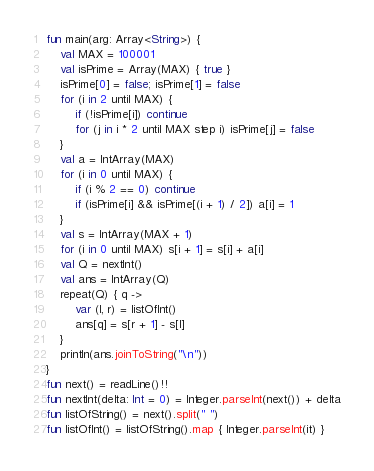Convert code to text. <code><loc_0><loc_0><loc_500><loc_500><_Kotlin_>fun main(arg: Array<String>) {
    val MAX = 100001
    val isPrime = Array(MAX) { true }
    isPrime[0] = false; isPrime[1] = false
    for (i in 2 until MAX) {
        if (!isPrime[i]) continue
        for (j in i * 2 until MAX step i) isPrime[j] = false
    }
    val a = IntArray(MAX)
    for (i in 0 until MAX) {
        if (i % 2 == 0) continue
        if (isPrime[i] && isPrime[(i + 1) / 2]) a[i] = 1
    }
    val s = IntArray(MAX + 1)
    for (i in 0 until MAX) s[i + 1] = s[i] + a[i]
    val Q = nextInt()
    val ans = IntArray(Q)
    repeat(Q) { q ->
        var (l, r) = listOfInt()
        ans[q] = s[r + 1] - s[l]
    }
    println(ans.joinToString("\n"))
}
fun next() = readLine()!!
fun nextInt(delta: Int = 0) = Integer.parseInt(next()) + delta
fun listOfString() = next().split(" ")
fun listOfInt() = listOfString().map { Integer.parseInt(it) }
</code> 